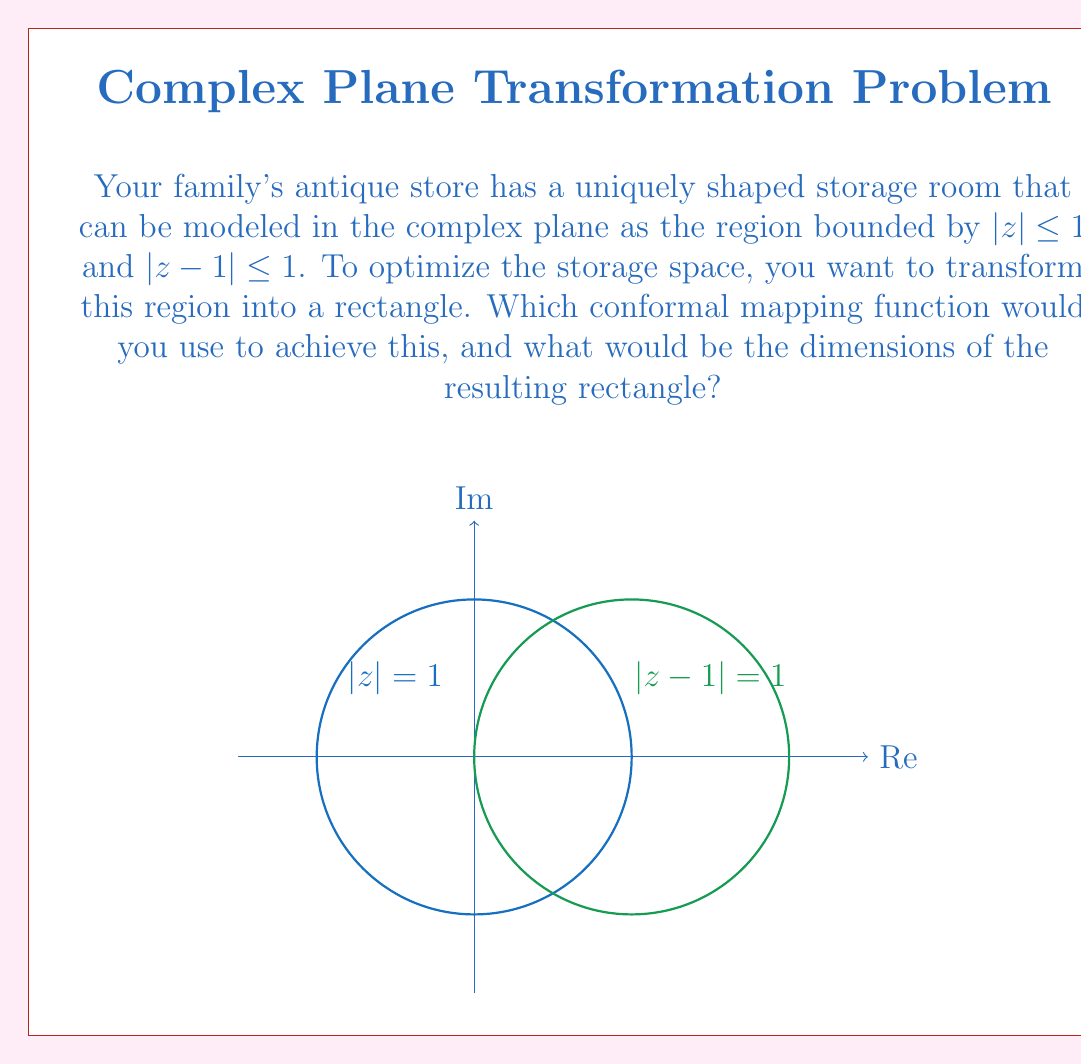Help me with this question. To solve this problem, we'll follow these steps:

1) The given region is the intersection of two unit circles, one centered at the origin and another at z = 1. This shape is known as a "lens" or "vesica piscis".

2) To transform this region into a rectangle, we can use the Joukowski transformation, followed by the natural logarithm function. The steps are:

   a) First, apply the Joukowski transformation: $w = z + \frac{1}{z}$
   b) Then, apply the natural logarithm: $\zeta = \ln(w)$

3) The Joukowski transformation maps the lens onto a line segment on the real axis from -2 to 2.

4) The natural logarithm then maps this line segment onto a rectangle.

5) To find the dimensions of the rectangle:
   - The real part of $\zeta$ will range from $\ln(2)$ to $-\ln(2)$, giving a width of $2\ln(2)$.
   - The imaginary part will range from $0$ to $\pi$, as the argument of $w$ ranges from $0$ to $\pi$ in the upper half-plane.

6) Therefore, the dimensions of the rectangle are $2\ln(2)$ by $\pi$.

The conformal mapping function is thus:

$$\zeta = \ln(z + \frac{1}{z})$$

This transforms the lens-shaped region into a rectangle of dimensions $2\ln(2)$ by $\pi$.
Answer: $\zeta = \ln(z + \frac{1}{z})$; $2\ln(2)$ by $\pi$ 